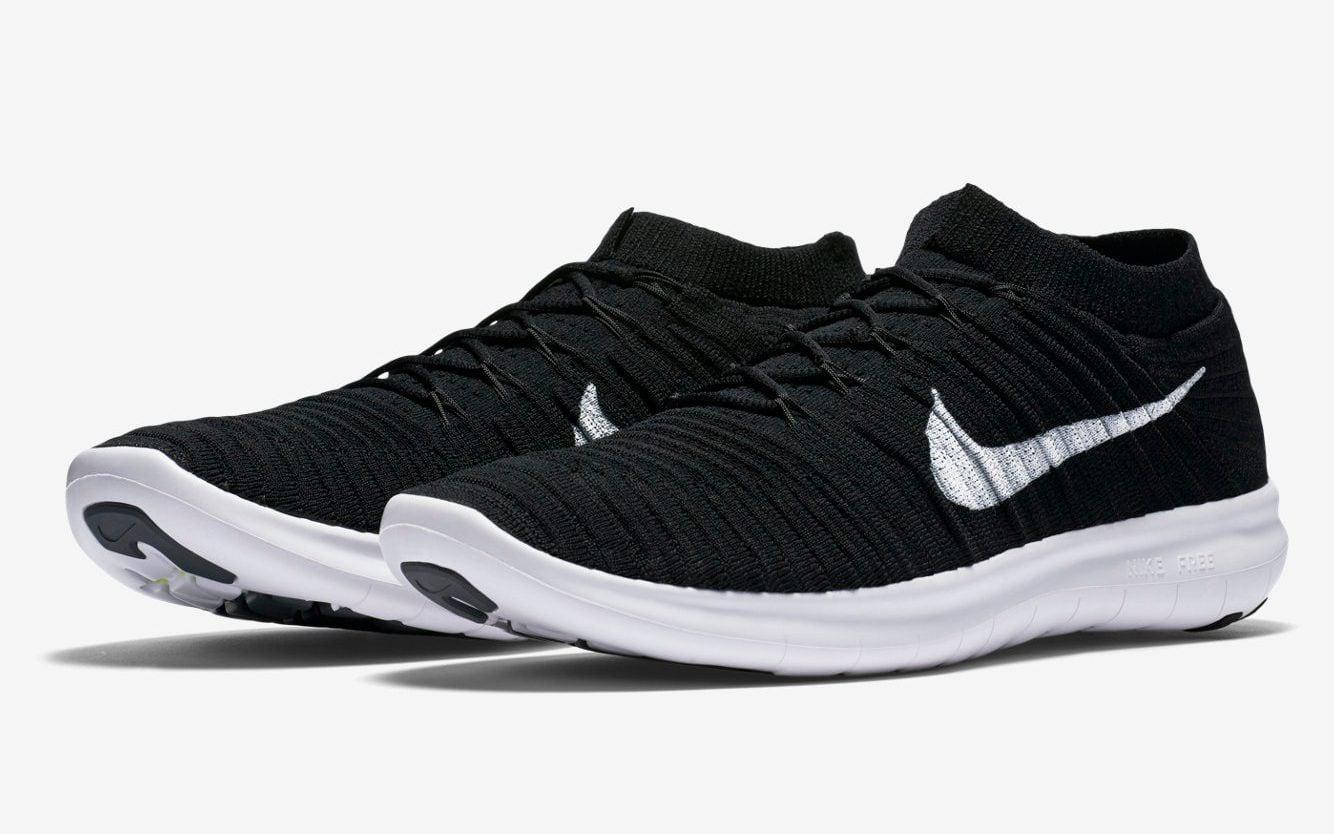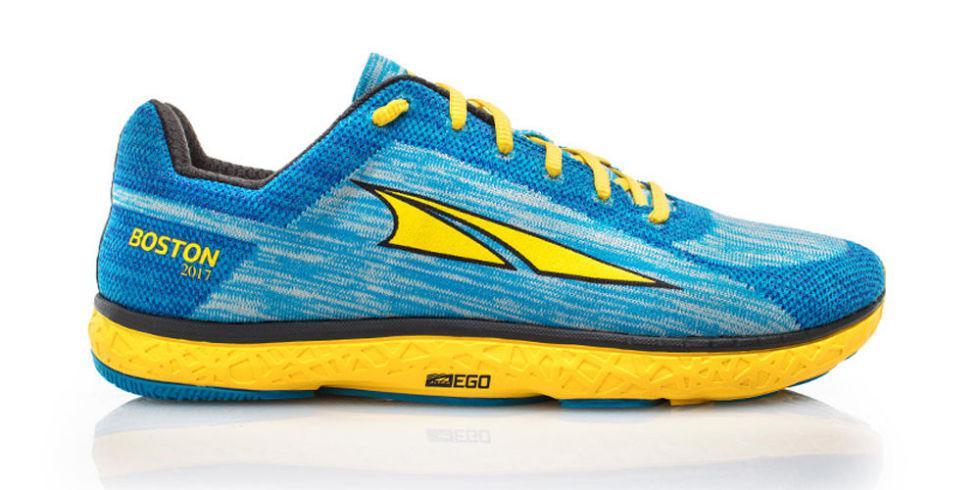The first image is the image on the left, the second image is the image on the right. Evaluate the accuracy of this statement regarding the images: "Both shoes are pointing to the right.". Is it true? Answer yes or no. No. The first image is the image on the left, the second image is the image on the right. Assess this claim about the two images: "Each image contains one right-facing shoe with bright colored treads on the bottom of the sole.". Correct or not? Answer yes or no. No. 